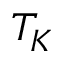<formula> <loc_0><loc_0><loc_500><loc_500>T _ { K }</formula> 